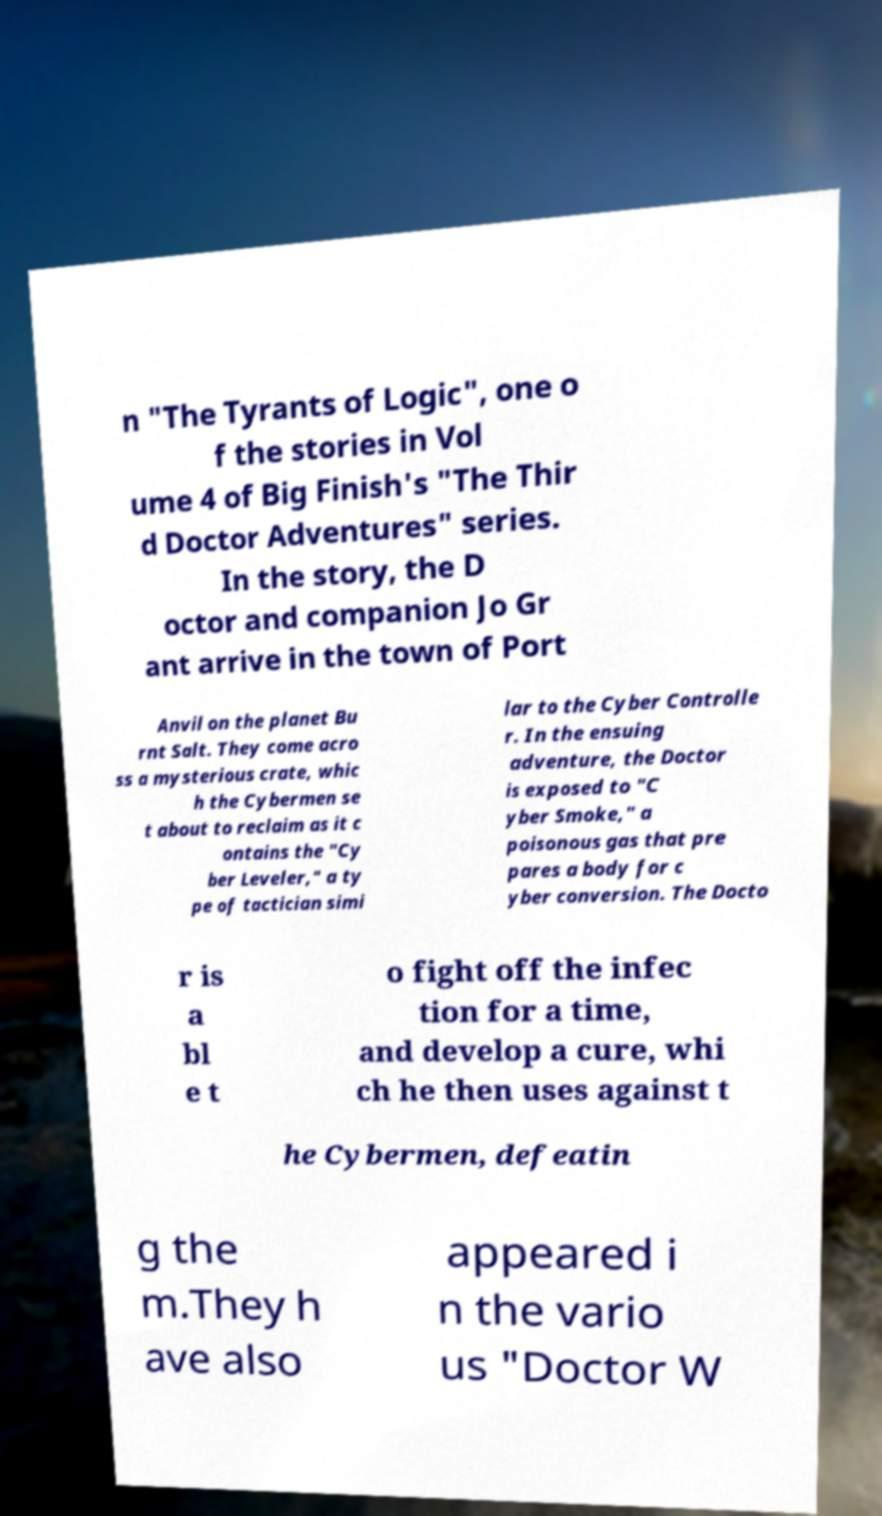What messages or text are displayed in this image? I need them in a readable, typed format. n "The Tyrants of Logic", one o f the stories in Vol ume 4 of Big Finish's "The Thir d Doctor Adventures" series. In the story, the D octor and companion Jo Gr ant arrive in the town of Port Anvil on the planet Bu rnt Salt. They come acro ss a mysterious crate, whic h the Cybermen se t about to reclaim as it c ontains the "Cy ber Leveler," a ty pe of tactician simi lar to the Cyber Controlle r. In the ensuing adventure, the Doctor is exposed to "C yber Smoke," a poisonous gas that pre pares a body for c yber conversion. The Docto r is a bl e t o fight off the infec tion for a time, and develop a cure, whi ch he then uses against t he Cybermen, defeatin g the m.They h ave also appeared i n the vario us "Doctor W 